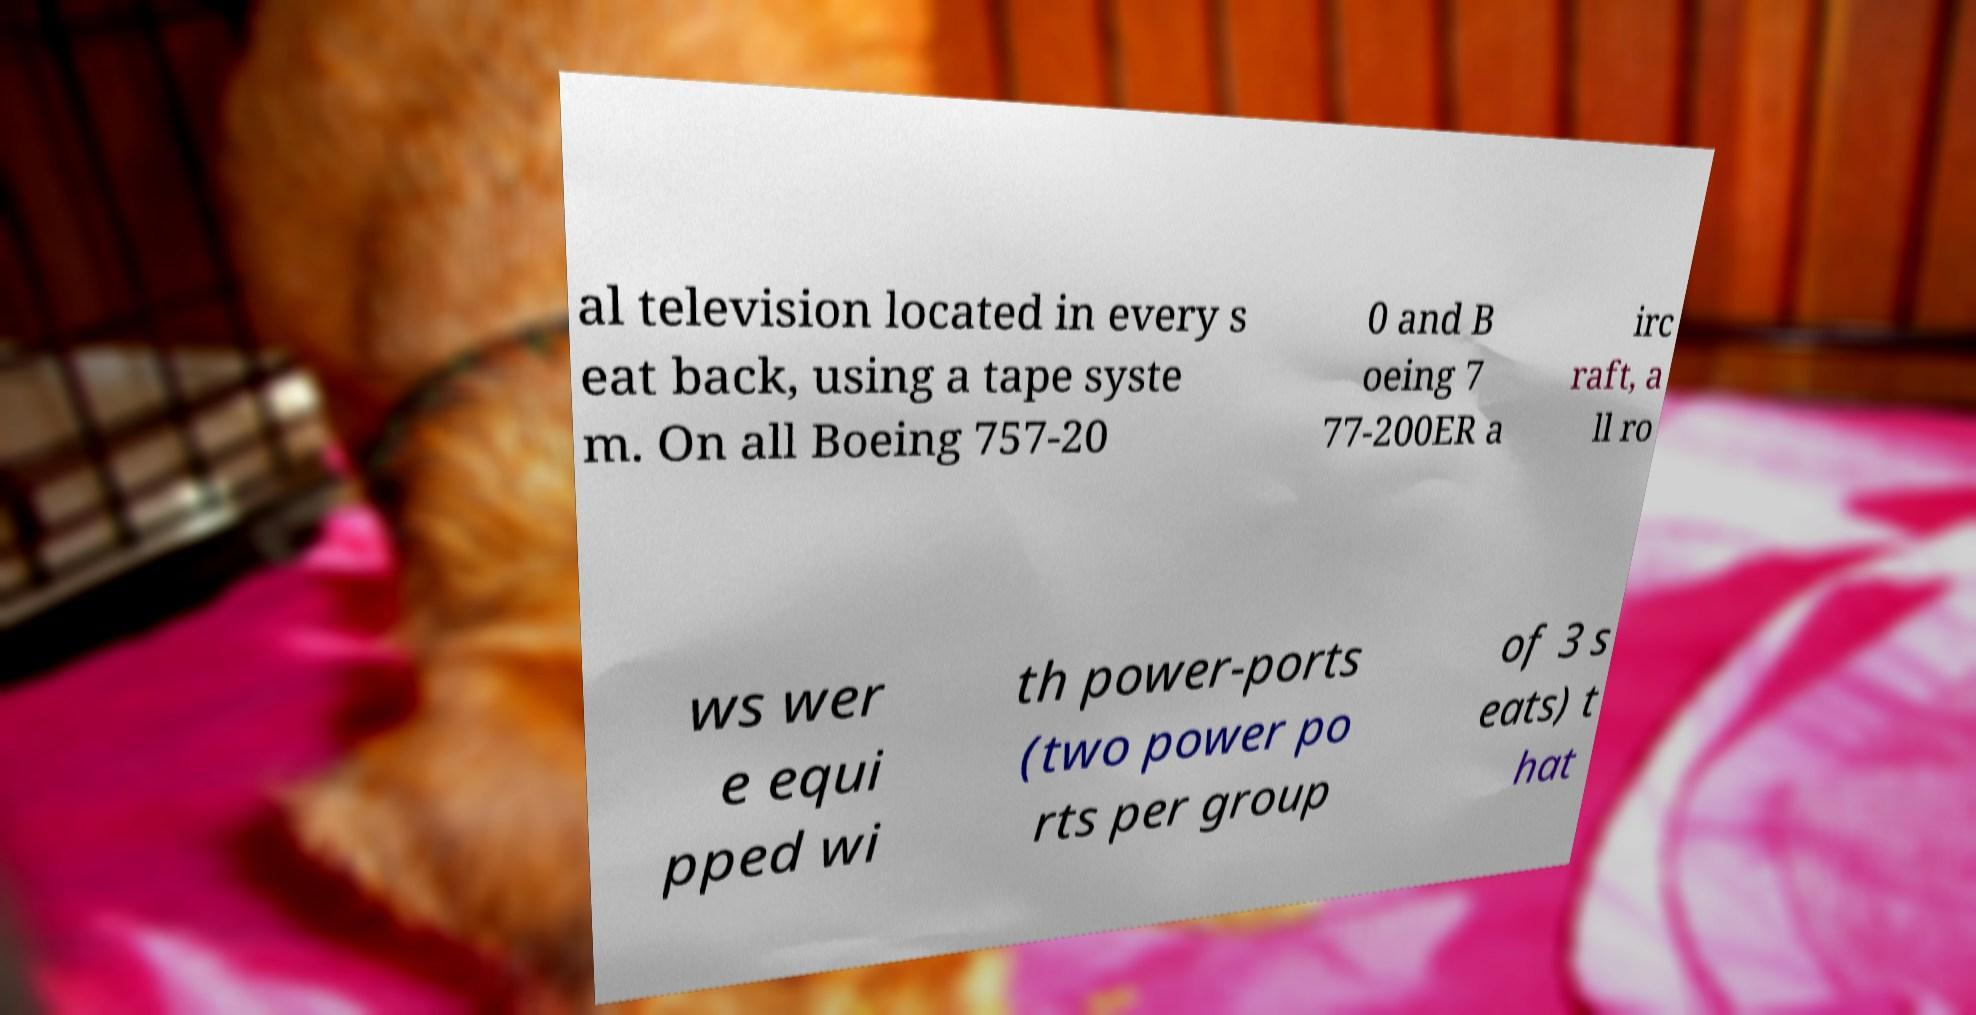Could you extract and type out the text from this image? al television located in every s eat back, using a tape syste m. On all Boeing 757-20 0 and B oeing 7 77-200ER a irc raft, a ll ro ws wer e equi pped wi th power-ports (two power po rts per group of 3 s eats) t hat 